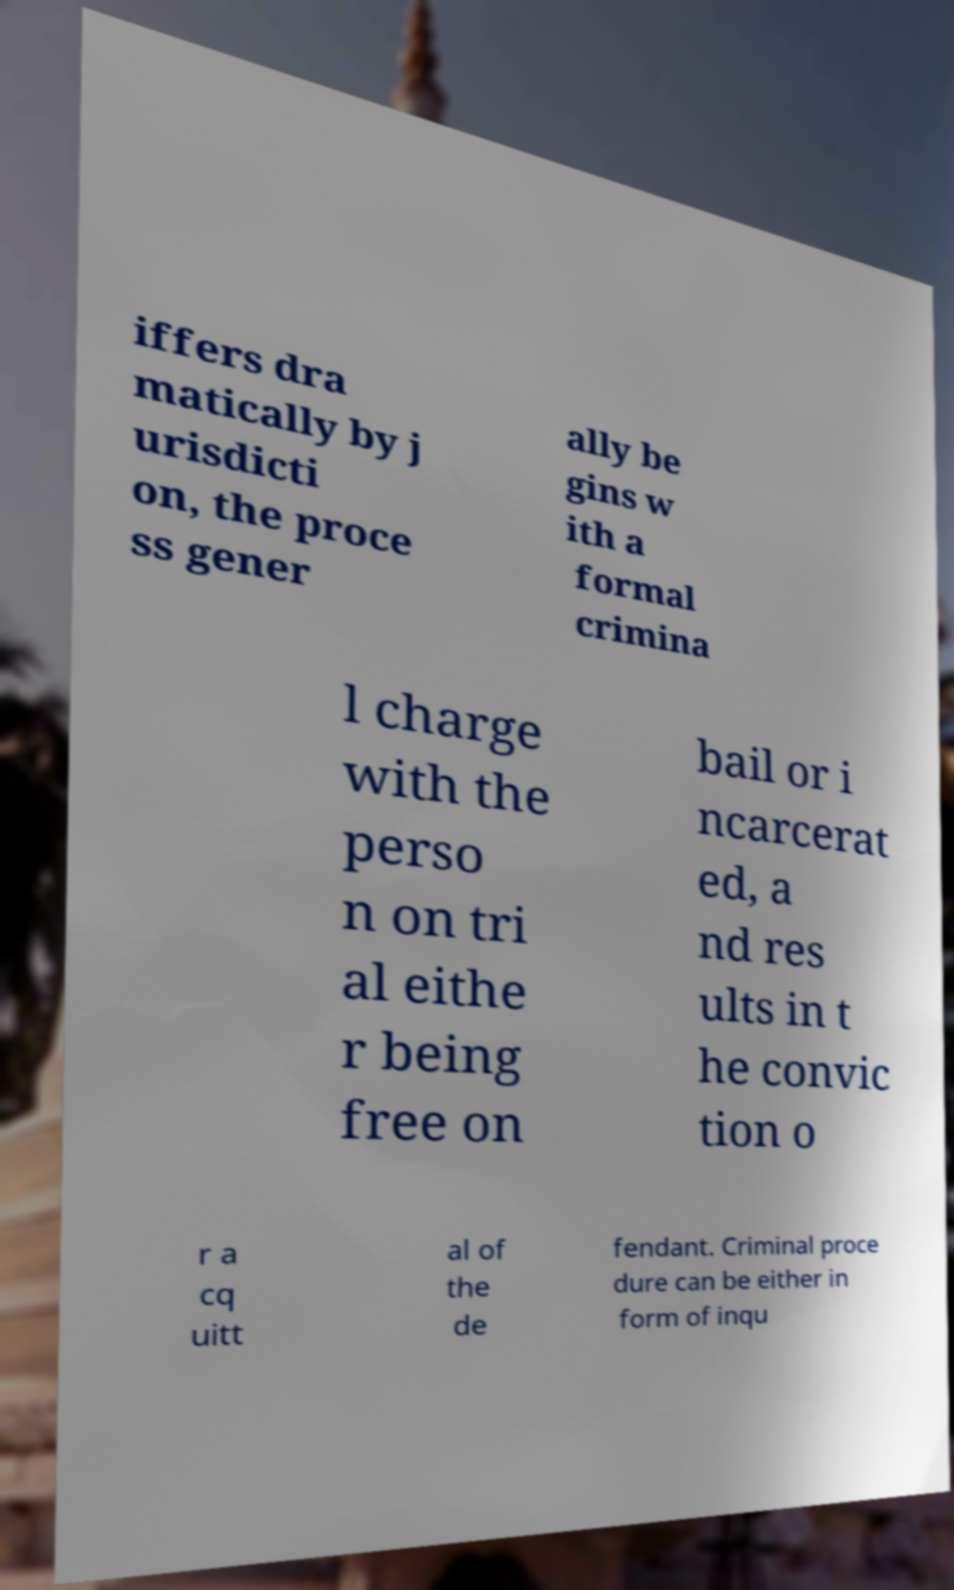Can you accurately transcribe the text from the provided image for me? iffers dra matically by j urisdicti on, the proce ss gener ally be gins w ith a formal crimina l charge with the perso n on tri al eithe r being free on bail or i ncarcerat ed, a nd res ults in t he convic tion o r a cq uitt al of the de fendant. Criminal proce dure can be either in form of inqu 